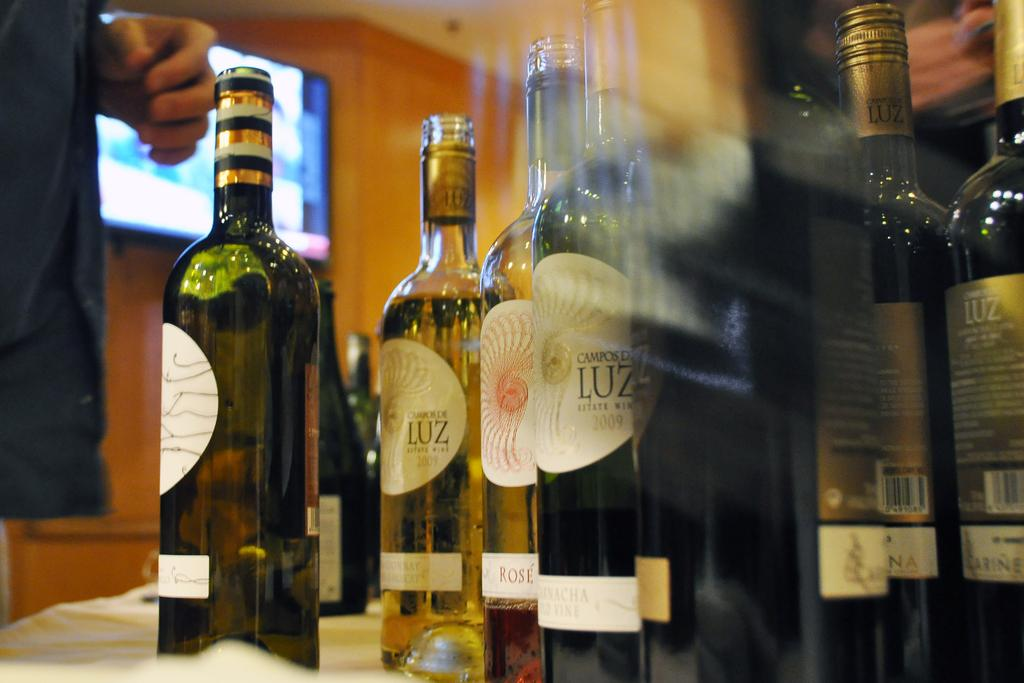Who is present in the image? There is a man in the image. What electronic device can be seen in the image? There is a television in the image. What objects are on the table in the image? There are bottles on a table in the image. What type of clover is growing on the man's head in the image? There is no clover present in the image; the man's head is not shown. 